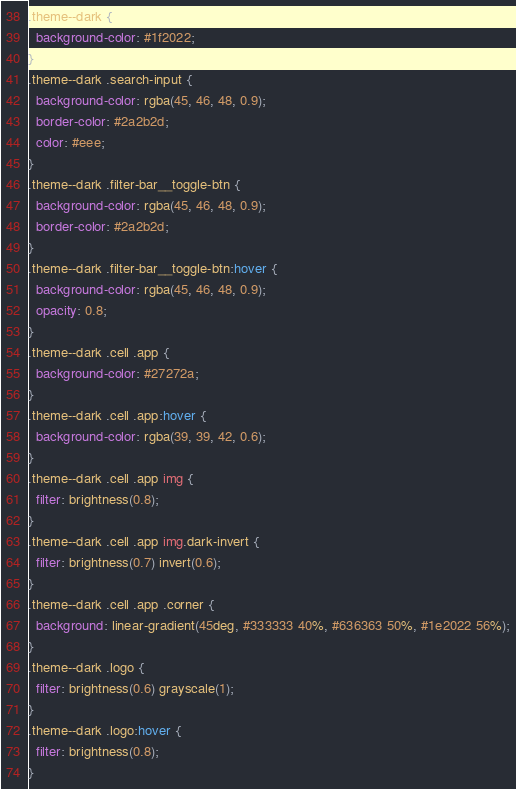<code> <loc_0><loc_0><loc_500><loc_500><_CSS_>.theme--dark {
  background-color: #1f2022;
}
.theme--dark .search-input {
  background-color: rgba(45, 46, 48, 0.9);
  border-color: #2a2b2d;
  color: #eee;
}
.theme--dark .filter-bar__toggle-btn {
  background-color: rgba(45, 46, 48, 0.9);
  border-color: #2a2b2d;
}
.theme--dark .filter-bar__toggle-btn:hover {
  background-color: rgba(45, 46, 48, 0.9);
  opacity: 0.8;
}
.theme--dark .cell .app {
  background-color: #27272a;
}
.theme--dark .cell .app:hover {
  background-color: rgba(39, 39, 42, 0.6);
}
.theme--dark .cell .app img {
  filter: brightness(0.8);
}
.theme--dark .cell .app img.dark-invert {
  filter: brightness(0.7) invert(0.6);
}
.theme--dark .cell .app .corner {
  background: linear-gradient(45deg, #333333 40%, #636363 50%, #1e2022 56%);
}
.theme--dark .logo {
  filter: brightness(0.6) grayscale(1);
}
.theme--dark .logo:hover {
  filter: brightness(0.8);
}
</code> 